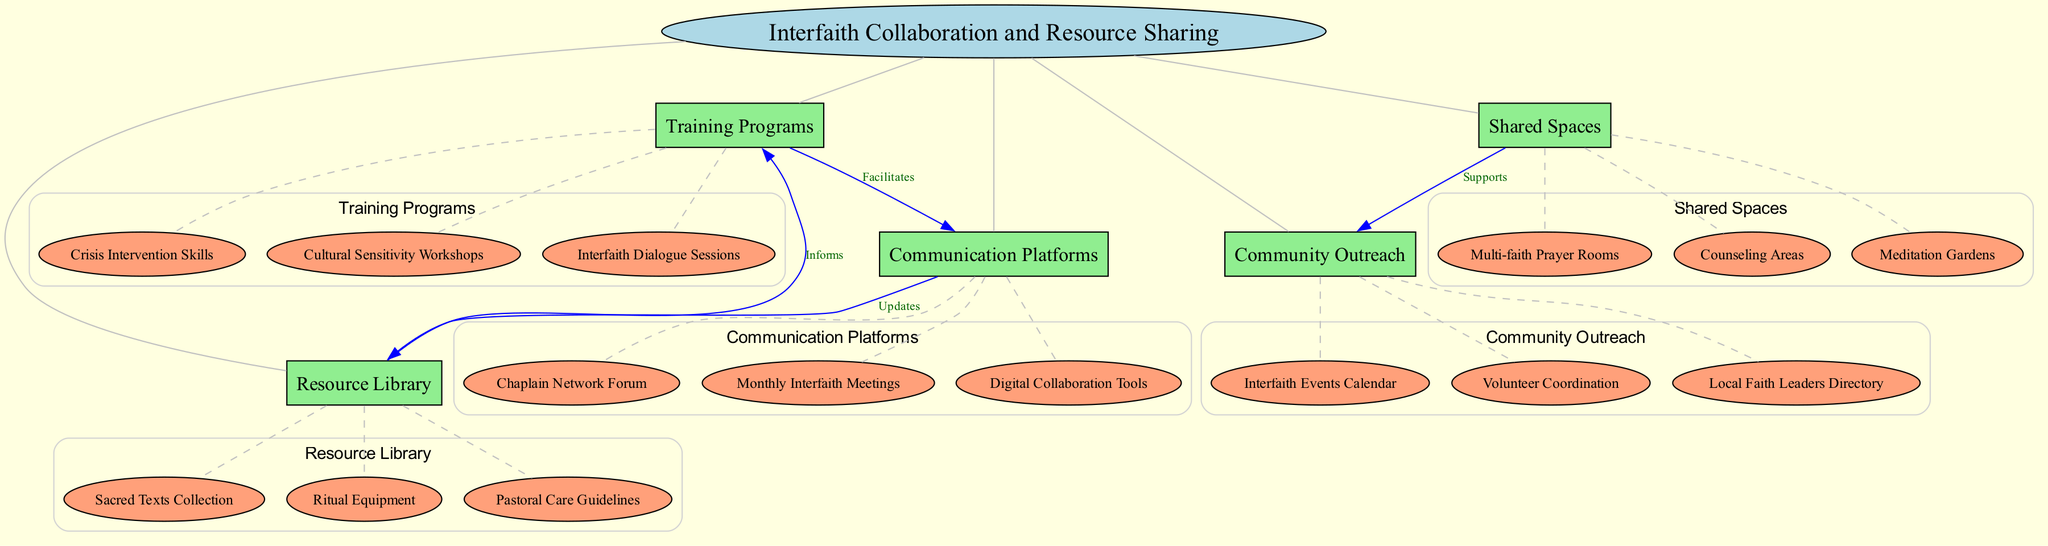What is the central concept in the diagram? The central concept labeled in the diagram is "Interfaith Collaboration and Resource Sharing." This is found at the center of the concept map within an ellipse shape.
Answer: Interfaith Collaboration and Resource Sharing How many main nodes are there? Counting the main nodes listed in the diagram, there are five: Training Programs, Shared Spaces, Communication Platforms, Resource Library, and Community Outreach.
Answer: 5 What workshops are included under Training Programs? The sub-nodes under Training Programs are Cultural Sensitivity Workshops, Interfaith Dialogue Sessions, and Crisis Intervention Skills, which are detailed in the section connected to the main node.
Answer: Cultural Sensitivity Workshops, Interfaith Dialogue Sessions, Crisis Intervention Skills What supports the Community Outreach node? The diagram indicates that Shared Spaces supports Community Outreach, as shown by the dashed arrow labeled "Supports" connecting these two nodes.
Answer: Shared Spaces Which node informs the Training Programs node? The Resource Library informs the Training Programs node, as indicated by the connection labeled "Informs" that directs from Resource Library to Training Programs.
Answer: Resource Library Which node utilizes Digital Collaboration Tools? The Communication Platforms node encompasses Digital Collaboration Tools, as it is one of the sub-nodes associated with Communication Platforms.
Answer: Communication Platforms How many connections are present in the diagram? There are four connections indicated in the diagram. Each connection relates different nodes to showcase their relationships, such as “Facilitates” and “Informs.”
Answer: 4 What type of spaces are included under Shared Spaces? Shared Spaces includes Multi-faith Prayer Rooms, Counseling Areas, and Meditation Gardens as its sub-nodes, which are listed in that section of the diagram.
Answer: Multi-faith Prayer Rooms, Counseling Areas, Meditation Gardens What is updated by Communication Platforms? The Resource Library is updated by the Communication Platforms node, evidenced by the connection labeled "Updates" leading from Communication Platforms to Resource Library.
Answer: Resource Library 